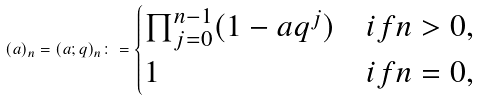<formula> <loc_0><loc_0><loc_500><loc_500>( a ) _ { n } = ( a ; q ) _ { n } \colon = \begin{cases} \prod _ { j = 0 } ^ { n - 1 } ( 1 - a q ^ { j } ) & i f n > 0 , \\ 1 & i f n = 0 , \end{cases}</formula> 